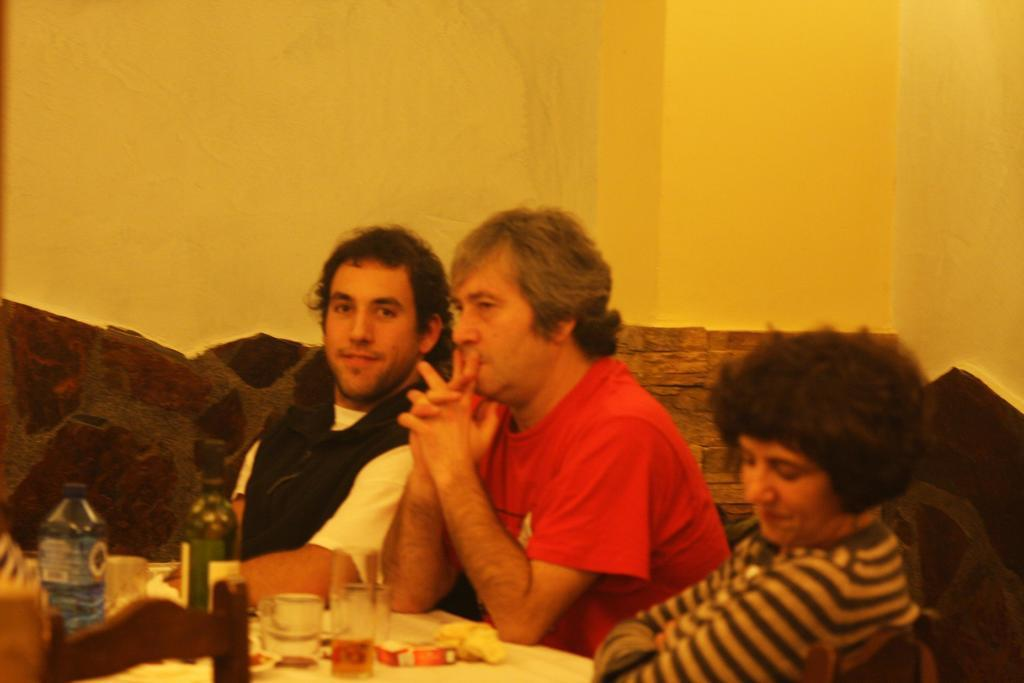What are the people in the image doing? The people in the image are sitting. What objects can be seen in the image that are typically used for drinking? There are glasses in the image. How many bottles are visible in the image? There are two bottles in the image. How many kittens are playing with a quill in the image? There are no kittens or quills present in the image. Is there a party happening in the image? There is no indication of a party in the image. 